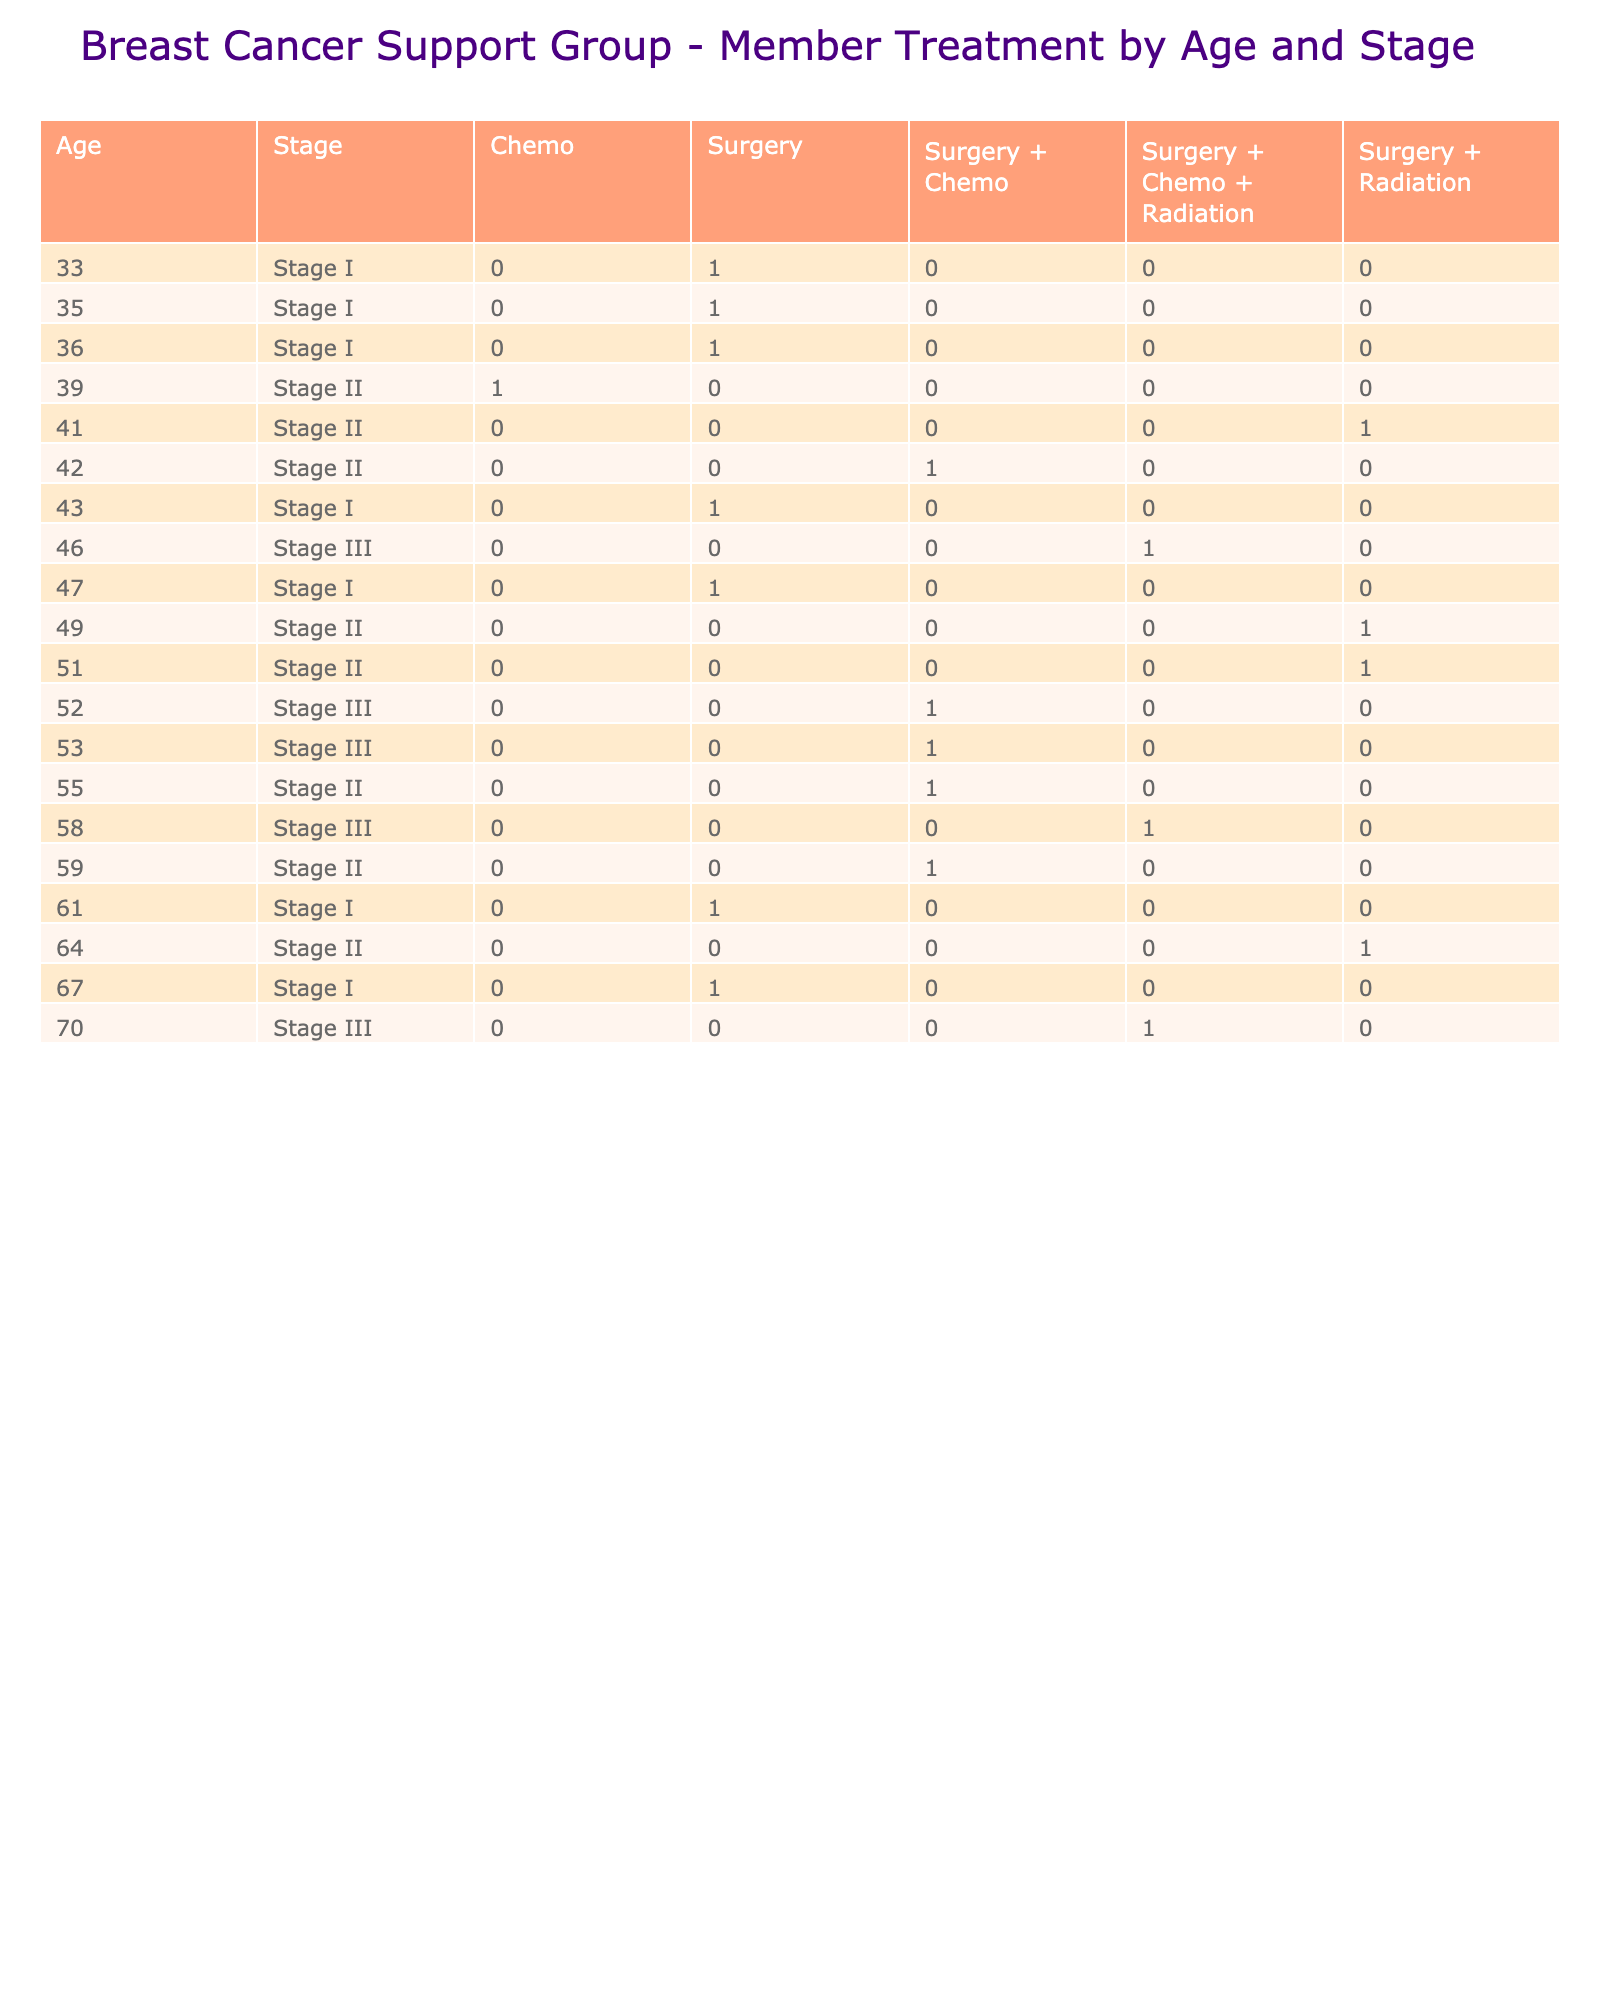What is the total number of members in Stage II treatment? In the table, we look under the 'Stage' heading for 'Stage II' and then count the corresponding 'Member_ID' values across different 'Treatment' types. There are five members listed under Stage II: Sarah Johnson, Patricia Brown, Jennifer Lee, Michelle King, and Kimberly Wright.
Answer: 5 How many members attended the meeting while undergoing Chemo treatment? We can check the 'Treatment' column for 'Chemo' and look at the 'Attendance' column to count those who have 'Yes' marked. In the data, the members who attended and are undergoing Chemo are Linda Thompson, Susan Miller, Kimberly Wright, and Helen Scott—four in total.
Answer: 4 Is there any member aged 70 or older receiving Surgery treatment? Looking at the 'Age' column, we find Dorothy Martin who is 70 years old and has listed 'Surgery + Chemo + Radiation' under treatment, not just Surgery. Therefore, no, there are no members 70 or older receiving only Surgery.
Answer: No What is the average age of members undergoing Surgery treatment? We identify all members with 'Surgery' as their treatment option (Emily Davis, Patricia Brown, Lisa Garcia, Ashley Rodriguez, and Carol Young), and note their ages are 35, 61, 36, 33, and 67. To find the average, we sum these ages (35 + 61 + 36 + 33 + 67 = 232) and divide by the number of members (5). Hence the average age is 232/5 = 46.4.
Answer: 46.4 Which stage has the highest attendance for members who underwent Radiation treatment? We filter for members having 'Radiation' in the 'Treatment' column and check their attendance. We find two members in Stage II (Nancy Anderson and Michelle King) and one member in Stage III (Helen Scott) attended. Since Stage II has two attendees compared to Stage III's one, Stage II has the highest attendance for Radiation treatment.
Answer: Stage II 